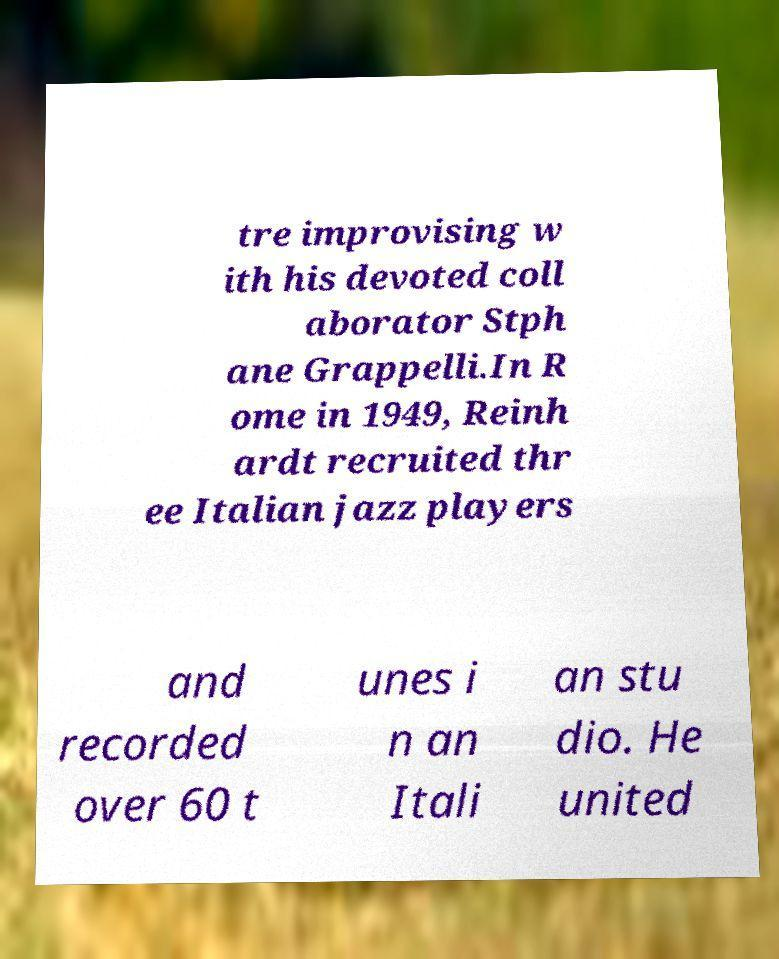Please read and relay the text visible in this image. What does it say? tre improvising w ith his devoted coll aborator Stph ane Grappelli.In R ome in 1949, Reinh ardt recruited thr ee Italian jazz players and recorded over 60 t unes i n an Itali an stu dio. He united 